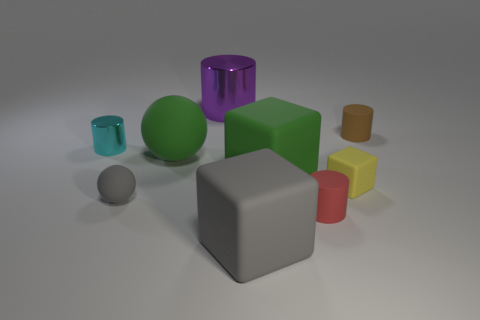What is the thing that is on the right side of the gray rubber cube and in front of the small matte sphere made of?
Provide a short and direct response. Rubber. The cylinder that is left of the tiny ball is what color?
Give a very brief answer. Cyan. Are there more big green rubber blocks in front of the red rubber cylinder than cyan matte things?
Offer a very short reply. No. What number of other things are there of the same size as the red cylinder?
Provide a succinct answer. 4. How many cylinders are right of the big purple metallic thing?
Give a very brief answer. 2. Are there the same number of small brown rubber cylinders on the left side of the green matte sphere and tiny matte things behind the big green block?
Offer a very short reply. No. The red rubber object that is the same shape as the small metallic object is what size?
Keep it short and to the point. Small. There is a small matte object that is behind the tiny yellow rubber thing; what shape is it?
Give a very brief answer. Cylinder. Do the large green thing in front of the big rubber ball and the sphere that is in front of the large green rubber block have the same material?
Give a very brief answer. Yes. What is the shape of the brown rubber thing?
Provide a succinct answer. Cylinder. 